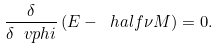<formula> <loc_0><loc_0><loc_500><loc_500>\frac { \delta } { \delta \ v p h i } \left ( E - \ h a l f \nu M \right ) = 0 .</formula> 